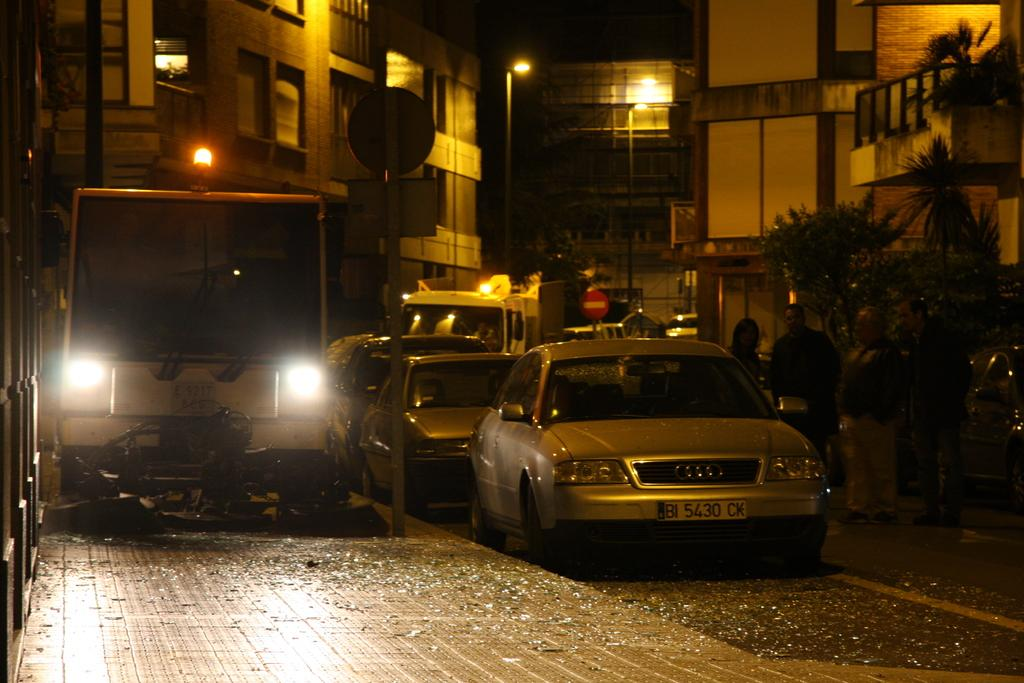What type of vehicles can be seen on the road in the image? There are motor vehicles on the road in the image. What are the people on the road doing? People are standing on the road in the image. What type of information might be conveyed by the sign boards in the image? The sign boards in the image might convey information about directions, rules, or advertisements. What are the street poles used for in the image? The street poles in the image are likely used for supporting street lights or sign boards. What type of lighting is present in the image? Street lights are present in the image. What type of vegetation is visible in the image? Trees are present in the image. What type of structures are visible in the image? Buildings are visible in the image. What type of flesh can be seen on the street lights in the image? There is no flesh present on the street lights in the image; they are made of metal or other inorganic materials. What year does the image depict? The image does not provide any information about the year it depicts. 